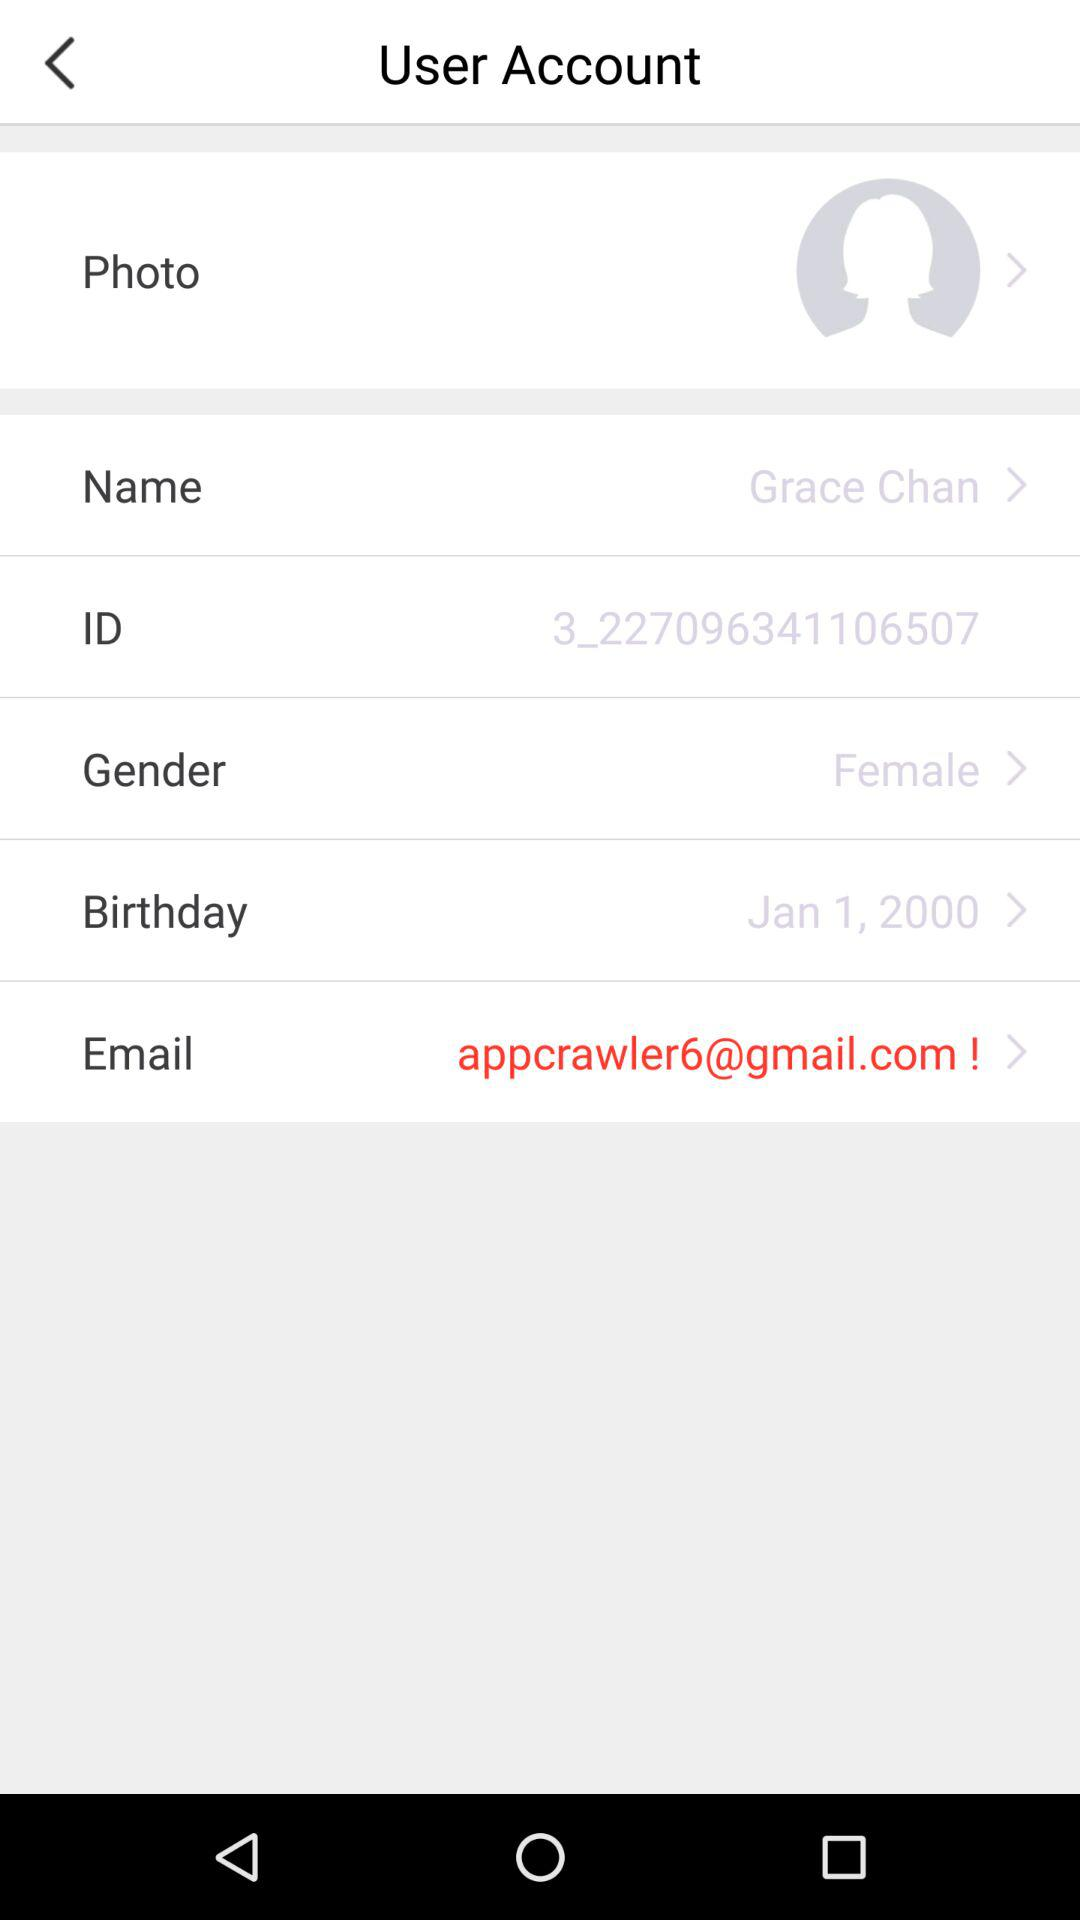What is the gender? The gender is female. 